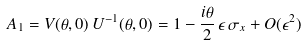Convert formula to latex. <formula><loc_0><loc_0><loc_500><loc_500>A _ { 1 } = V ( \theta , 0 ) \, U ^ { - 1 } ( \theta , 0 ) = 1 - \frac { i \theta } { 2 } \, \epsilon \, \sigma _ { x } + O ( \epsilon ^ { 2 } )</formula> 